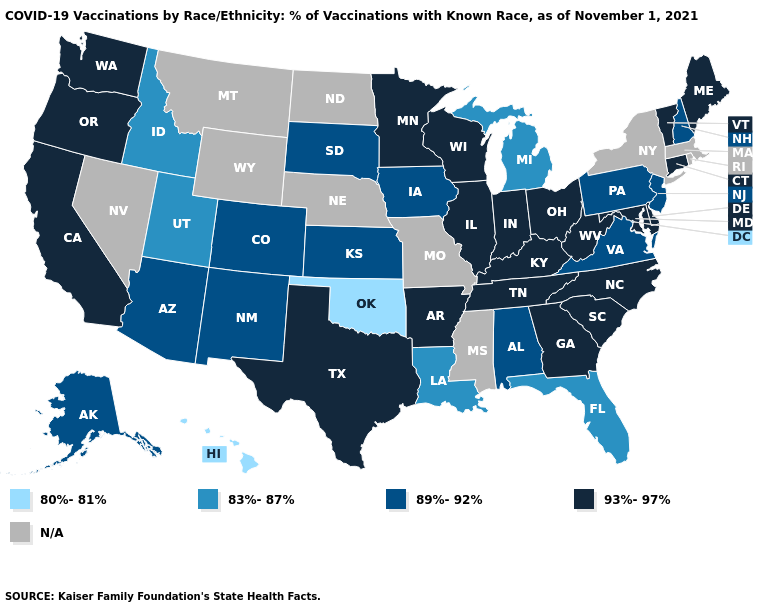Does the first symbol in the legend represent the smallest category?
Be succinct. Yes. Among the states that border Minnesota , which have the highest value?
Be succinct. Wisconsin. Name the states that have a value in the range 80%-81%?
Keep it brief. Hawaii, Oklahoma. Which states hav the highest value in the West?
Keep it brief. California, Oregon, Washington. Which states have the highest value in the USA?
Be succinct. Arkansas, California, Connecticut, Delaware, Georgia, Illinois, Indiana, Kentucky, Maine, Maryland, Minnesota, North Carolina, Ohio, Oregon, South Carolina, Tennessee, Texas, Vermont, Washington, West Virginia, Wisconsin. Among the states that border Montana , which have the highest value?
Keep it brief. South Dakota. Does the map have missing data?
Give a very brief answer. Yes. What is the lowest value in states that border Rhode Island?
Answer briefly. 93%-97%. What is the value of Hawaii?
Answer briefly. 80%-81%. Name the states that have a value in the range 89%-92%?
Quick response, please. Alabama, Alaska, Arizona, Colorado, Iowa, Kansas, New Hampshire, New Jersey, New Mexico, Pennsylvania, South Dakota, Virginia. What is the highest value in the West ?
Answer briefly. 93%-97%. Name the states that have a value in the range 93%-97%?
Write a very short answer. Arkansas, California, Connecticut, Delaware, Georgia, Illinois, Indiana, Kentucky, Maine, Maryland, Minnesota, North Carolina, Ohio, Oregon, South Carolina, Tennessee, Texas, Vermont, Washington, West Virginia, Wisconsin. Does Ohio have the lowest value in the USA?
Be succinct. No. Which states have the highest value in the USA?
Short answer required. Arkansas, California, Connecticut, Delaware, Georgia, Illinois, Indiana, Kentucky, Maine, Maryland, Minnesota, North Carolina, Ohio, Oregon, South Carolina, Tennessee, Texas, Vermont, Washington, West Virginia, Wisconsin. 